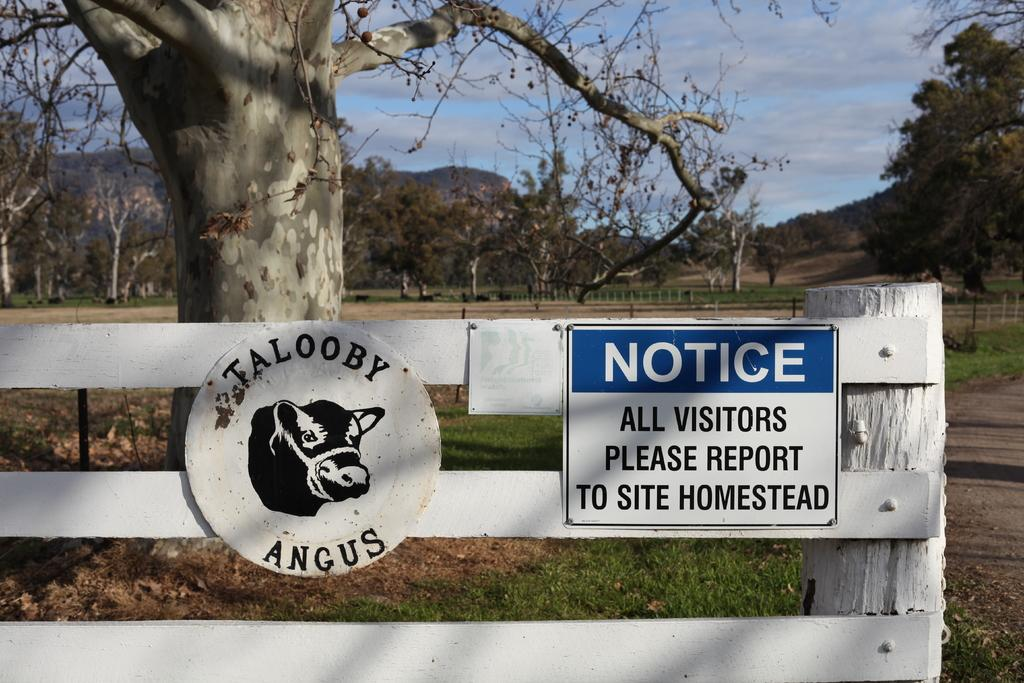What is located in the foreground of the image? There is a wooden railing in the foreground of the image. What is attached to the railing? There are boards on the railing. What can be seen behind the railing? There is a tree behind the railing. What else is visible in the background of the image? There are trees and mountains in the background of the image, as well as the sky. Can you describe the sky in the image? The sky is visible in the background of the image, and there is a cloud present. What type of nut is being used to write on the boards in the image? There is no nut or writing present on the boards in the image. What type of fruit is hanging from the tree behind the railing? There is no fruit visible on the tree behind the railing in the image. 